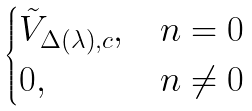Convert formula to latex. <formula><loc_0><loc_0><loc_500><loc_500>\begin{cases} \tilde { V } _ { \Delta ( \lambda ) , c } , & n = 0 \\ 0 , & n \ne 0 \end{cases}</formula> 